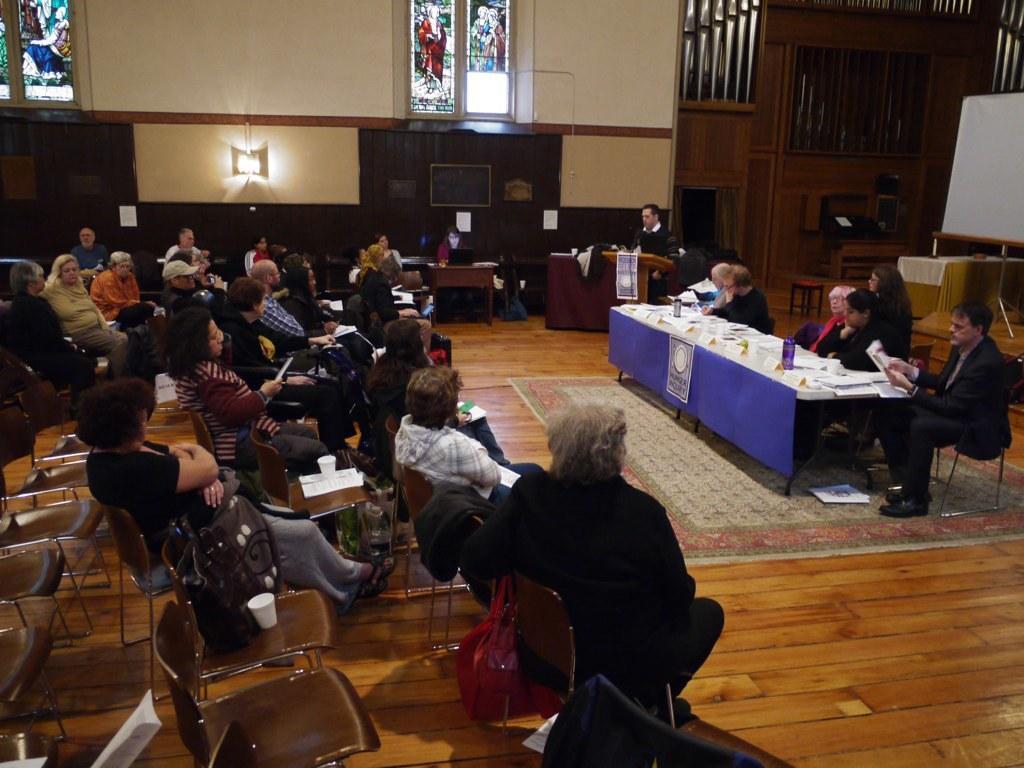Describe this image in one or two sentences. This picture is taken inside a room. There are people sitting on the chairs. There are tables, stall, board, lights and carpet on the floor in the room. In the right corner there is a table on which bottles, boards and papers are placed. On chairs there are also papers, paper cups and bags placed. On the window there is an art.  